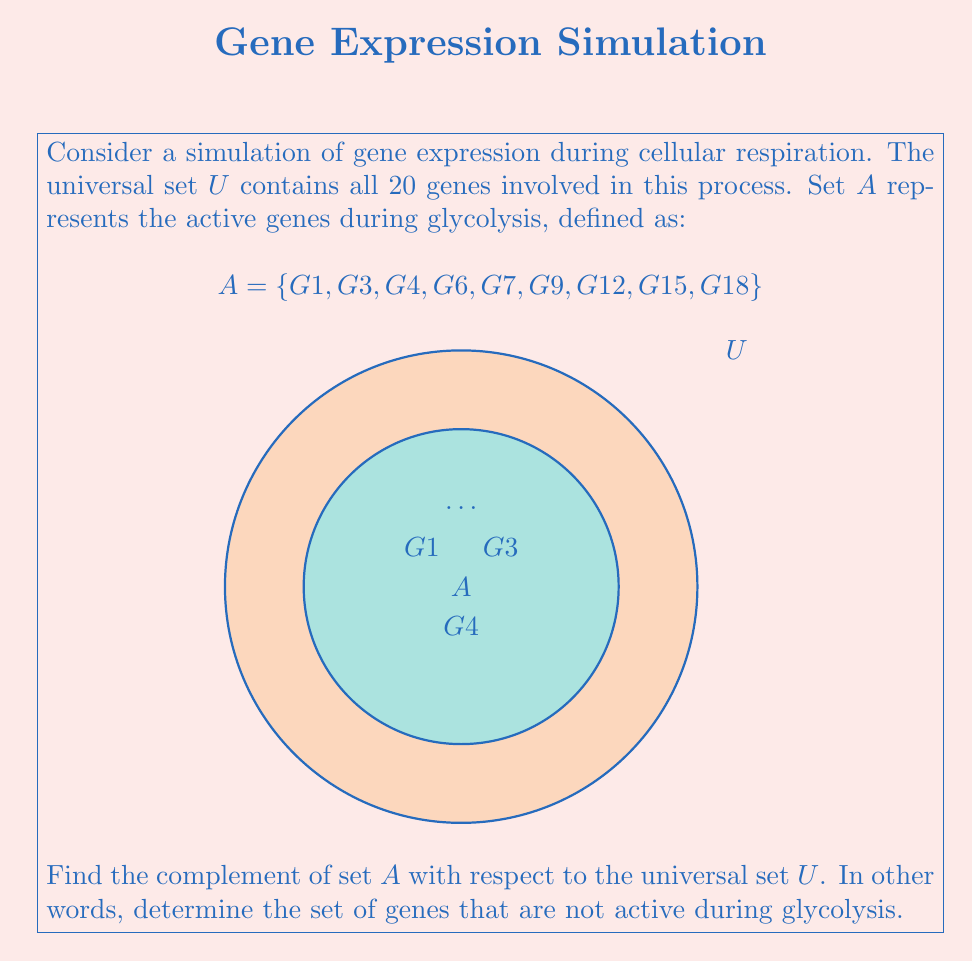Teach me how to tackle this problem. To find the complement of set $A$, we need to identify all elements in the universal set $U$ that are not in set $A$. Let's approach this step-by-step:

1) First, recall that the complement of set $A$, denoted as $A^c$ or $\overline{A}$, is defined as:

   $A^c = \{x \in U : x \notin A\}$

2) We know that $U$ contains all 20 genes involved in cellular respiration, labeled from G1 to G20.

3) Set $A$ contains the active genes during glycolysis: $\{G1, G3, G4, G6, G7, G9, G12, G15, G18\}$

4) To find $A^c$, we need to list all genes in $U$ that are not in $A$:

   $A^c = \{G2, G5, G8, G10, G11, G13, G14, G16, G17, G19, G20\}$

5) We can verify our answer by checking that:
   - Every element in $A^c$ is in $U$ but not in $A$
   - The number of elements in $A$ (9) plus the number of elements in $A^c$ (11) equals the total number of elements in $U$ (20)

Thus, we have successfully found the complement of set $A$, which represents the genes that are not active during glycolysis in our simulation.
Answer: $A^c = \{G2, G5, G8, G10, G11, G13, G14, G16, G17, G19, G20\}$ 